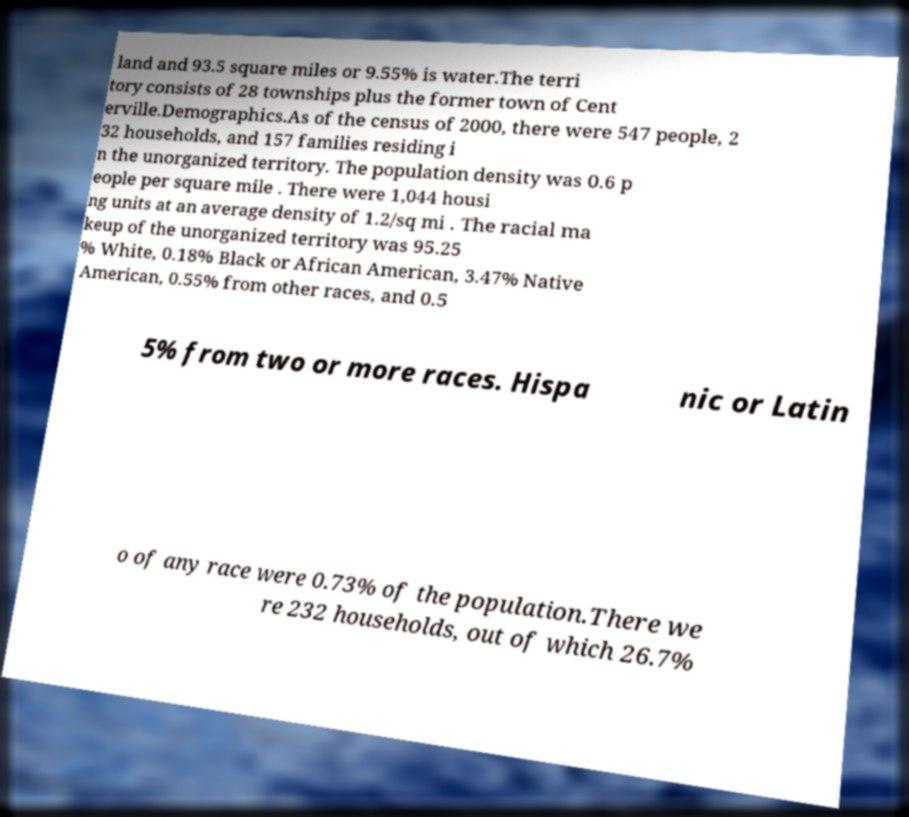For documentation purposes, I need the text within this image transcribed. Could you provide that? land and 93.5 square miles or 9.55% is water.The terri tory consists of 28 townships plus the former town of Cent erville.Demographics.As of the census of 2000, there were 547 people, 2 32 households, and 157 families residing i n the unorganized territory. The population density was 0.6 p eople per square mile . There were 1,044 housi ng units at an average density of 1.2/sq mi . The racial ma keup of the unorganized territory was 95.25 % White, 0.18% Black or African American, 3.47% Native American, 0.55% from other races, and 0.5 5% from two or more races. Hispa nic or Latin o of any race were 0.73% of the population.There we re 232 households, out of which 26.7% 